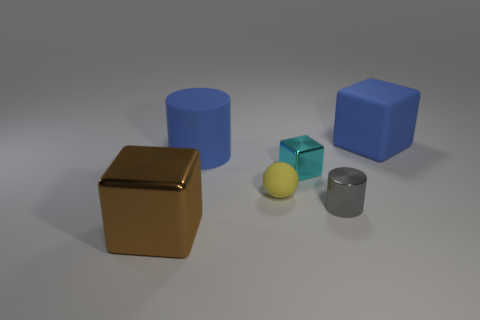There is a cylinder that is in front of the blue rubber cylinder; is its size the same as the tiny cube?
Your answer should be very brief. Yes. Is the color of the small cylinder the same as the ball?
Offer a very short reply. No. What number of rubber balls are there?
Ensure brevity in your answer.  1. How many cubes are brown things or tiny cyan shiny things?
Make the answer very short. 2. How many small cylinders are behind the gray shiny thing that is right of the yellow rubber ball?
Offer a very short reply. 0. Is the material of the tiny yellow sphere the same as the gray object?
Give a very brief answer. No. There is a matte cylinder that is the same color as the matte block; what is its size?
Offer a very short reply. Large. Is there a cyan cylinder made of the same material as the large blue block?
Your response must be concise. No. What is the color of the cylinder that is in front of the blue thing that is in front of the cube that is behind the tiny cyan cube?
Ensure brevity in your answer.  Gray. What number of cyan objects are either big shiny cubes or shiny cubes?
Provide a succinct answer. 1. 